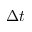Convert formula to latex. <formula><loc_0><loc_0><loc_500><loc_500>\Delta t</formula> 